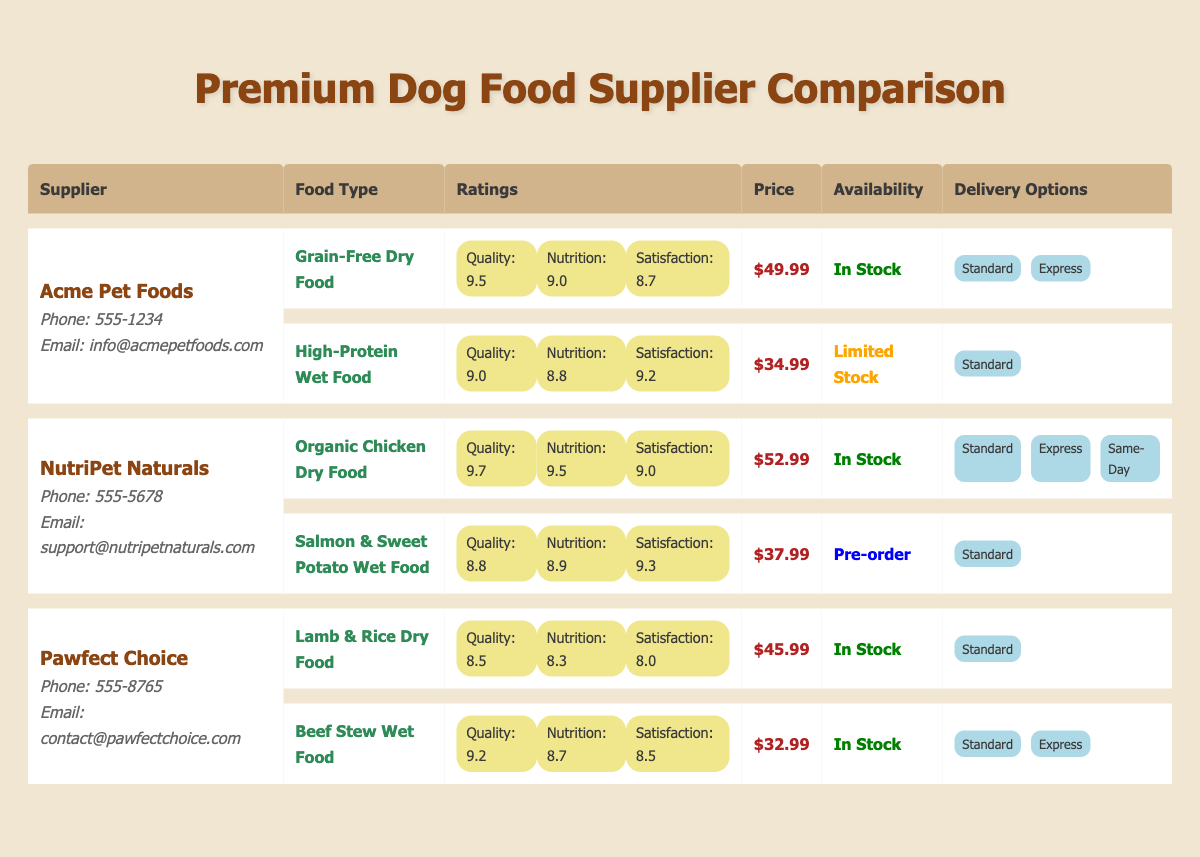What is the price of the Organic Chicken Dry Food from NutriPet Naturals? The price of the Organic Chicken Dry Food from NutriPet Naturals is listed directly in the table under the price column for that food type. It is $52.99.
Answer: $52.99 Which supplier offers High-Protein Wet Food, and what is its customer satisfaction rating? The supplier that offers High-Protein Wet Food is Acme Pet Foods. The customer satisfaction rating for this food type is listed in the ratings column and is 9.2.
Answer: Acme Pet Foods, 9.2 Is the Beef Stew Wet Food available for same-day delivery? The Beef Stew Wet Food from Pawfect Choice is only available with Standard and Express delivery options, which means same-day delivery is not offered.
Answer: No What is the average quality rating of all food types from the supplier NutriPet Naturals? For NutriPet Naturals, the quality ratings of their food types are 9.7 for Organic Chicken Dry Food and 8.8 for Salmon & Sweet Potato Wet Food. The average is calculated as (9.7 + 8.8) / 2 = 9.25.
Answer: 9.25 Which food type has the highest nutritional value rating, and from which supplier? Upon reviewing the nutritional value ratings in the table, the Organic Chicken Dry Food from NutriPet Naturals has the highest rating of 9.5. It is the only food type with this value.
Answer: Organic Chicken Dry Food from NutriPet Naturals What is the difference in price between the Grain-Free Dry Food from Acme Pet Foods and the Lamb & Rice Dry Food from Pawfect Choice? The price of the Grain-Free Dry Food is $49.99, and the price of the Lamb & Rice Dry Food is $45.99. To find the difference, subtract the lower price from the higher price: $49.99 - $45.99 = $4.00.
Answer: $4.00 Which supplier provides the option for Same-Day delivery, and which food type is eligible? Only NutriPet Naturals provides Same-Day delivery option for their Organic Chicken Dry Food. This information can be found under the delivery options column next to the food type.
Answer: NutriPet Naturals, Organic Chicken Dry Food Is the Salmon & Sweet Potato Wet Food in stock? The Salmon & Sweet Potato Wet Food is marked as Pre-order in the table, indicating that it is not currently in stock.
Answer: No 